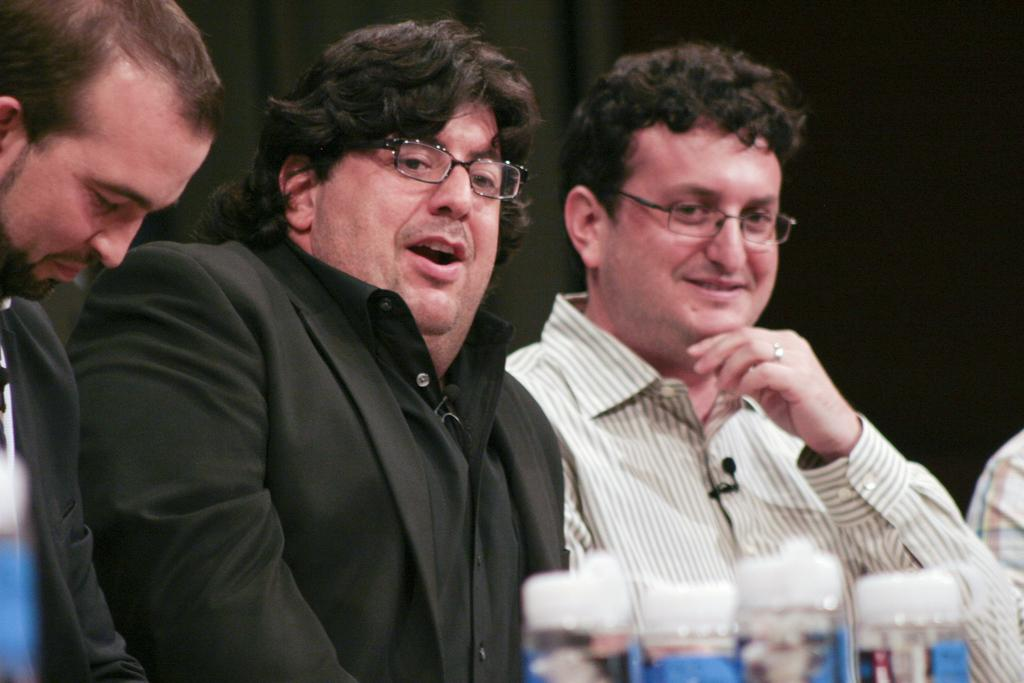How many men are in the image? There are two men in the image. What expression do the men have? The men are smiling. Can you describe the people on the sides of the image? There are two people on the right and left side of the image. What objects can be seen in the image? There are bottles visible in the image. What is the color of the background in the image? The background of the image is black. What type of music can be heard in the image? There is no music present in the image; it is a still photograph. Can you tell me how many visitors are in the image? The term "visitor" is not mentioned in the provided facts, and there is no indication of any visitors in the image. 